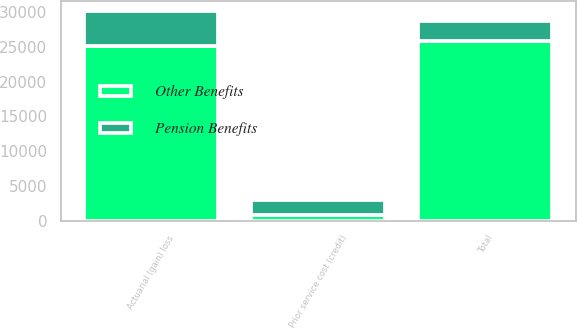Convert chart to OTSL. <chart><loc_0><loc_0><loc_500><loc_500><stacked_bar_chart><ecel><fcel>Actuarial (gain) loss<fcel>Prior service cost (credit)<fcel>Total<nl><fcel>Other Benefits<fcel>25108<fcel>754<fcel>25862<nl><fcel>Pension Benefits<fcel>5009<fcel>2189<fcel>2820<nl></chart> 